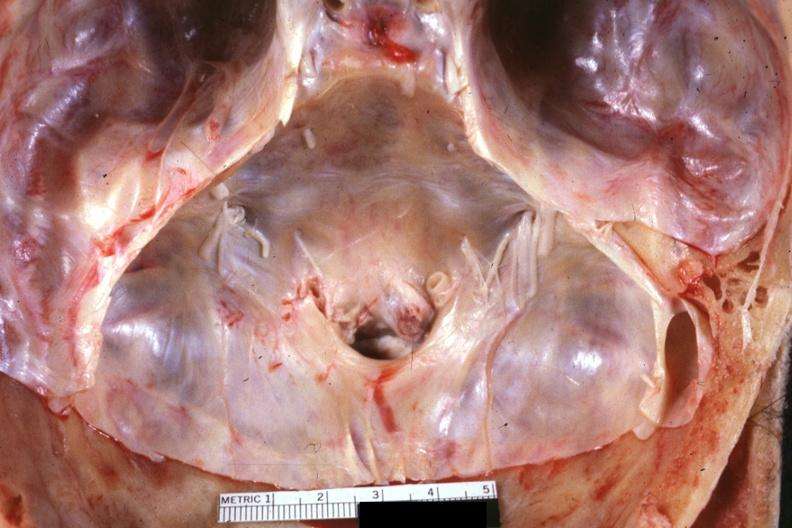s benign cystic teratoma present?
Answer the question using a single word or phrase. No 